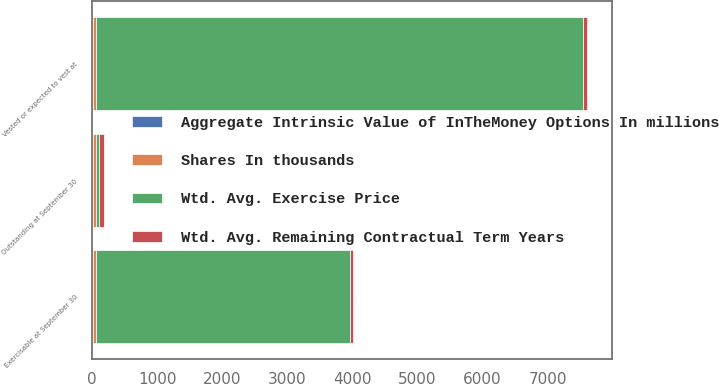Convert chart to OTSL. <chart><loc_0><loc_0><loc_500><loc_500><stacked_bar_chart><ecel><fcel>Outstanding at September 30<fcel>Vested or expected to vest at<fcel>Exercisable at September 30<nl><fcel>Wtd. Avg. Exercise Price<fcel>51.4<fcel>7480<fcel>3911<nl><fcel>Shares In thousands<fcel>51.46<fcel>51.4<fcel>50.01<nl><fcel>Aggregate Intrinsic Value of InTheMoney Options In millions<fcel>6.8<fcel>6.8<fcel>5.3<nl><fcel>Wtd. Avg. Remaining Contractual Term Years<fcel>72.4<fcel>69.6<fcel>37<nl></chart> 